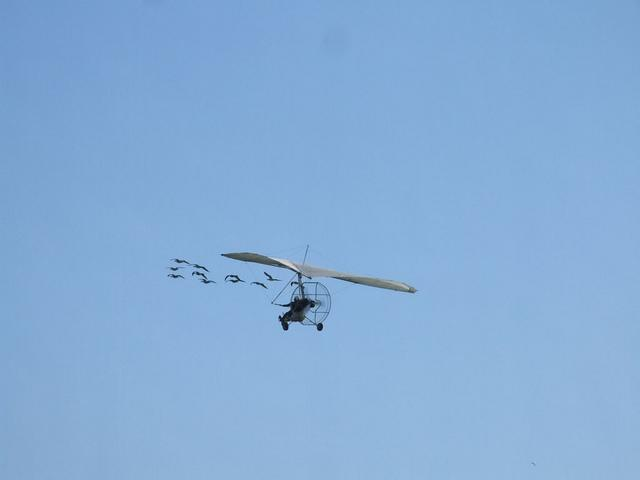Which object is/are in the greatest threat?

Choices:
A) pilot
B) birds
C) plane wings
D) plane wheels birds 